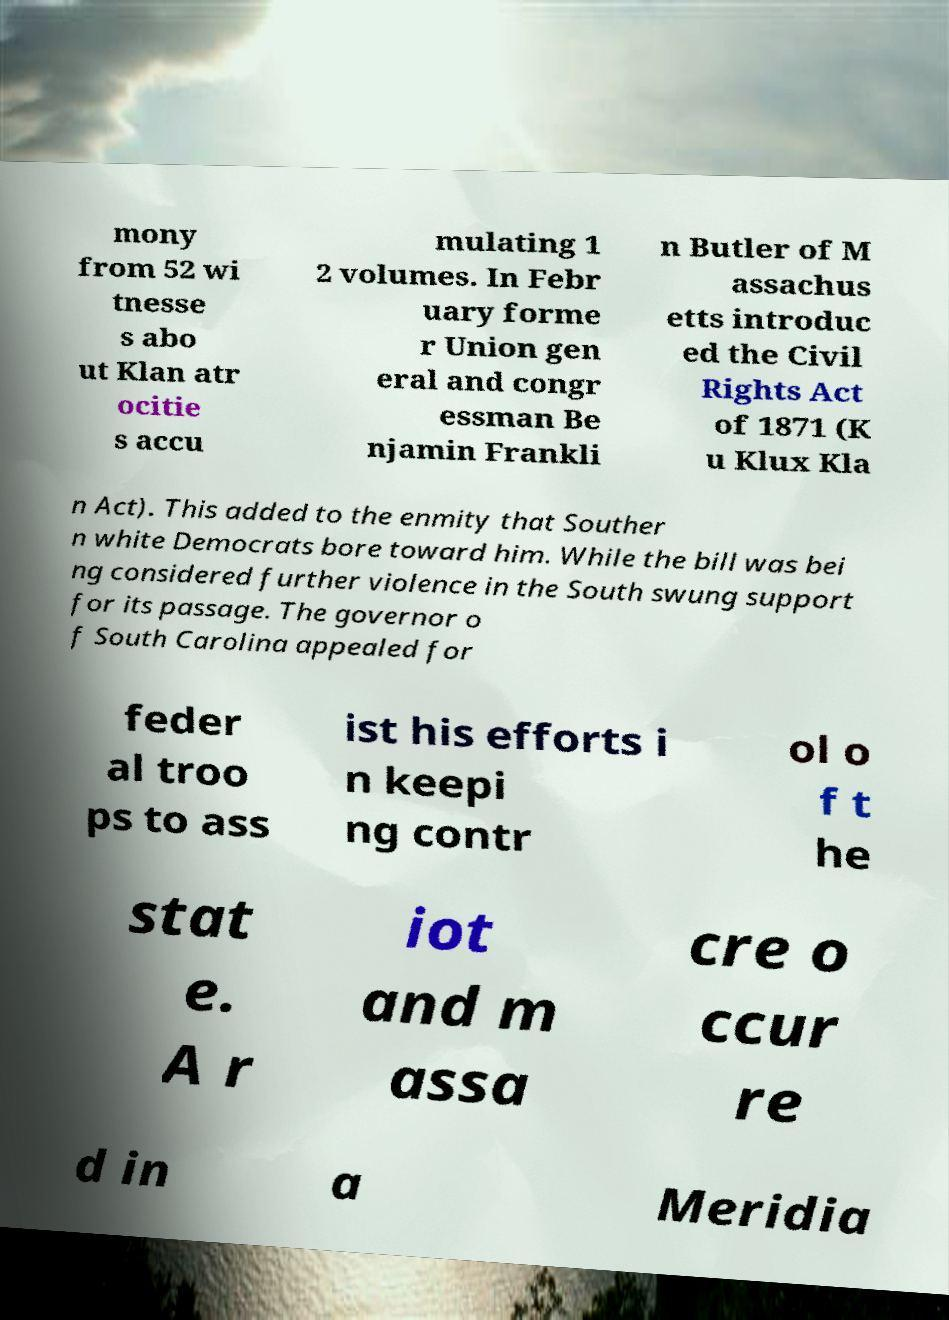Could you extract and type out the text from this image? mony from 52 wi tnesse s abo ut Klan atr ocitie s accu mulating 1 2 volumes. In Febr uary forme r Union gen eral and congr essman Be njamin Frankli n Butler of M assachus etts introduc ed the Civil Rights Act of 1871 (K u Klux Kla n Act). This added to the enmity that Souther n white Democrats bore toward him. While the bill was bei ng considered further violence in the South swung support for its passage. The governor o f South Carolina appealed for feder al troo ps to ass ist his efforts i n keepi ng contr ol o f t he stat e. A r iot and m assa cre o ccur re d in a Meridia 